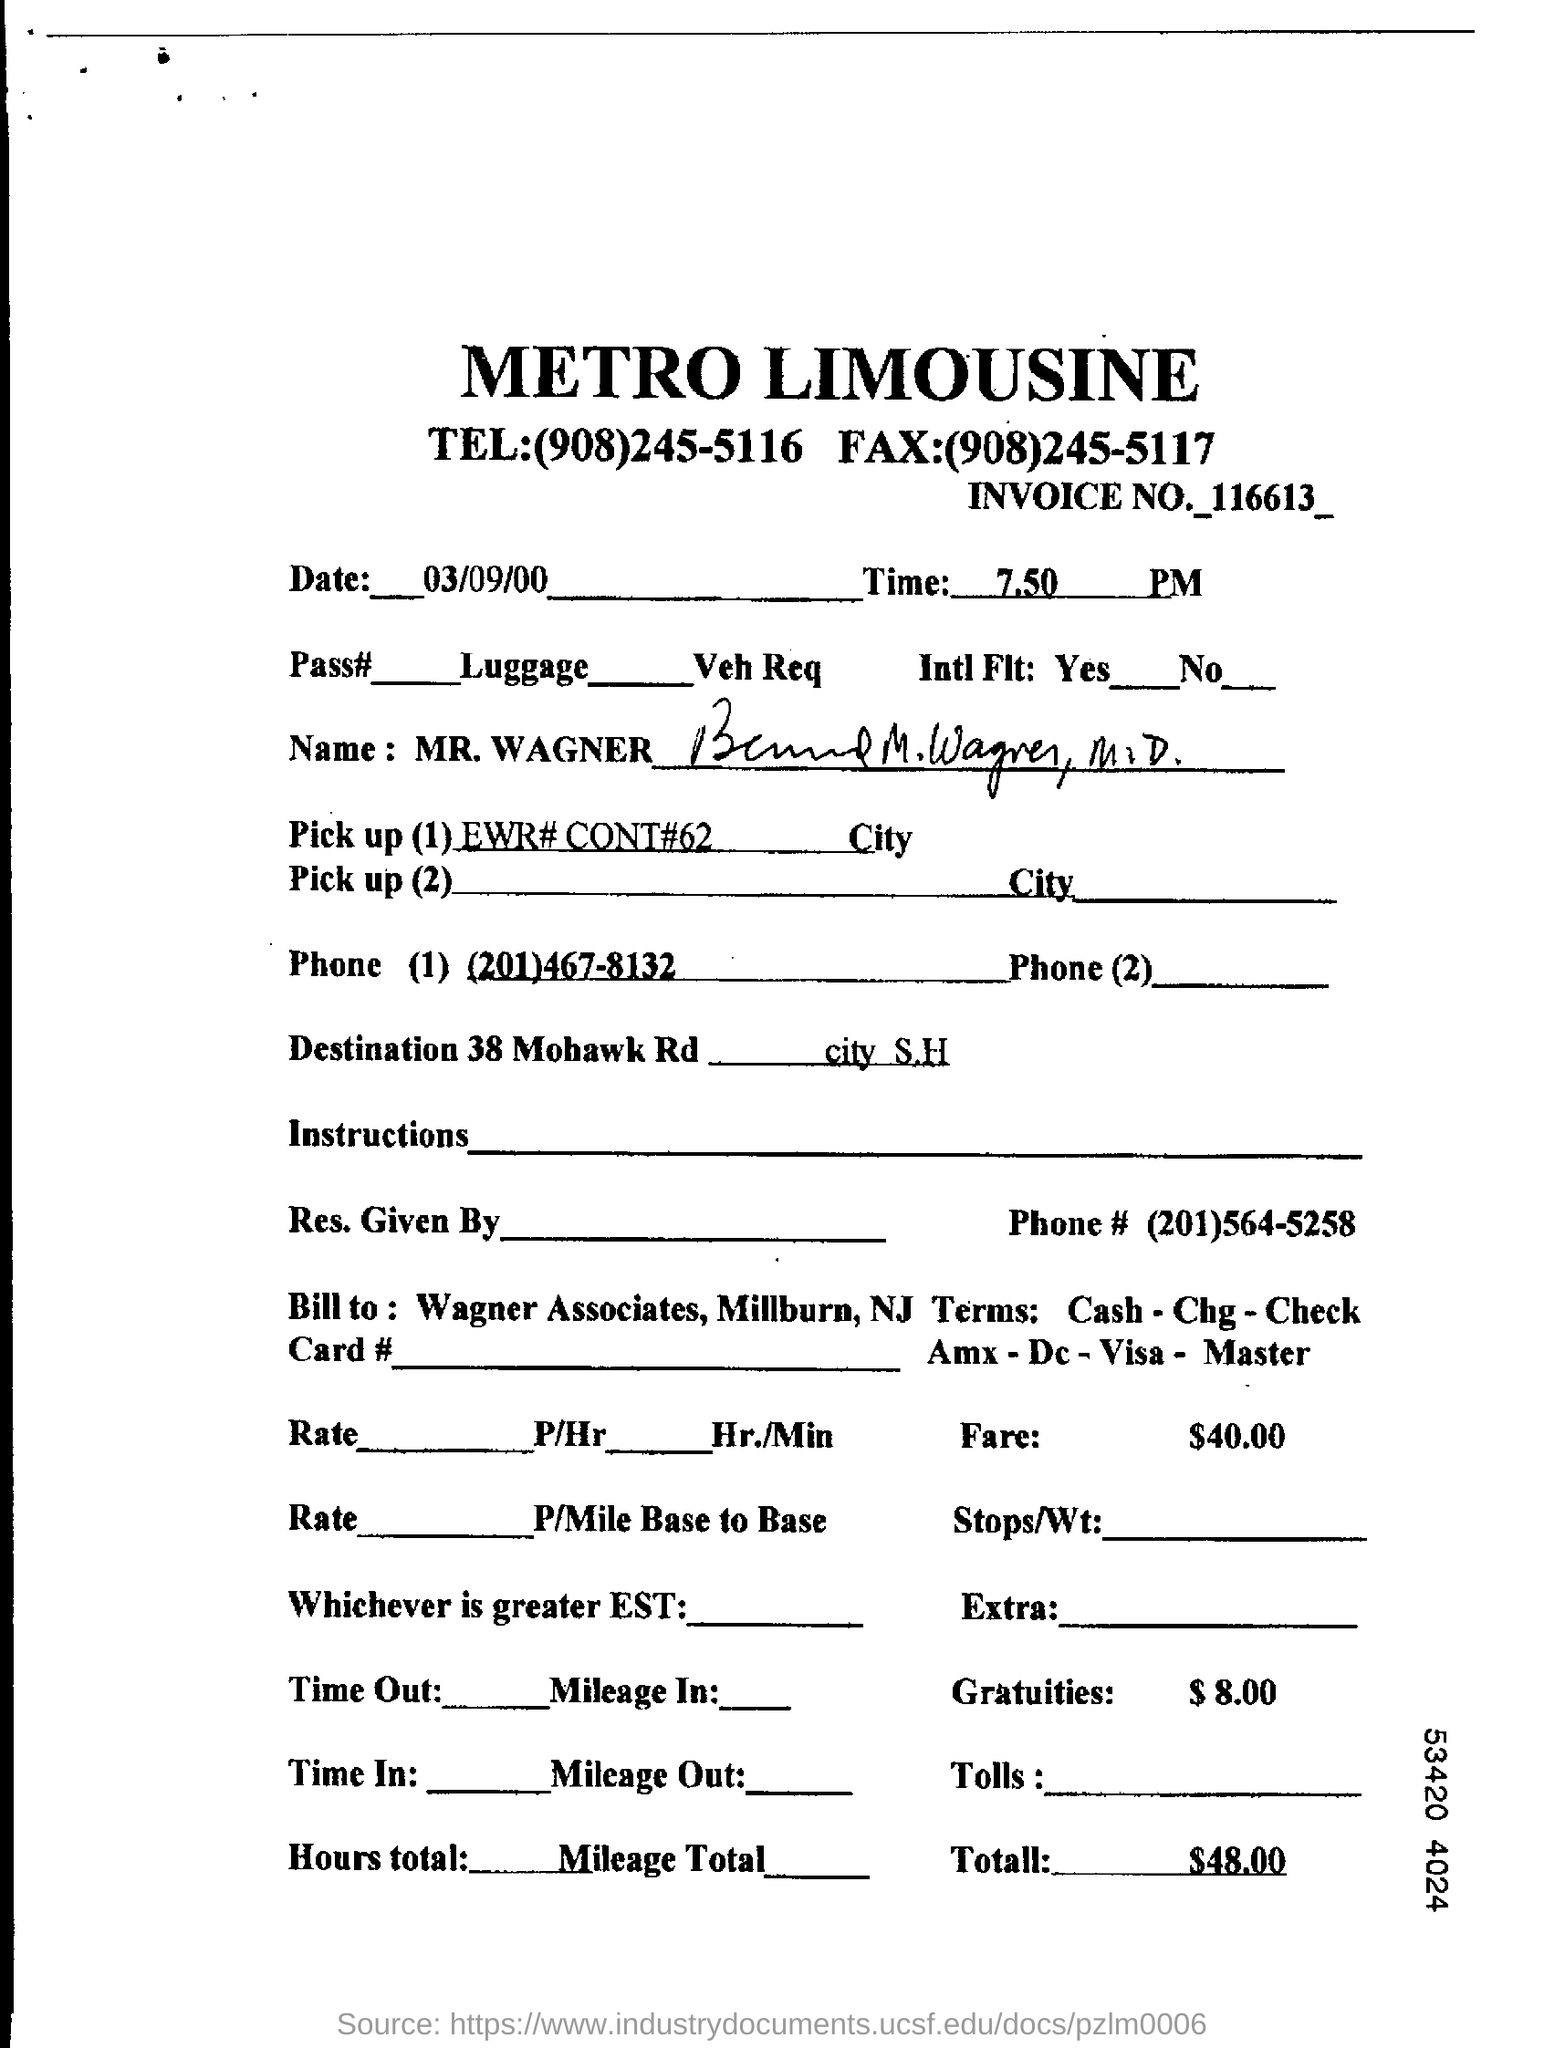Identify some key points in this picture. The fax number for Metro Limousine is (908)245-5117. The total amount is $48.00. The fare amount is $40.00. What is the invoice number? It is 116613 and... The time mentioned at the top of the document is 7:50 PM. 